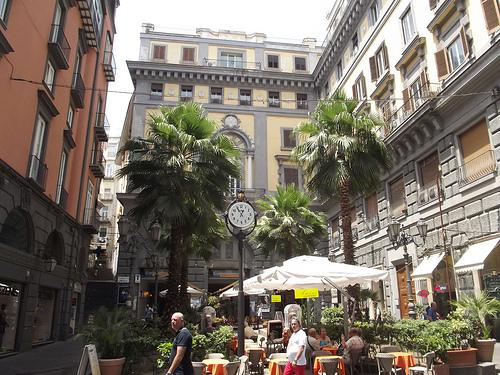Question: what color is the building on the right?
Choices:
A. Yellow.
B. White.
C. Brown.
D. Orange.
Answer with the letter. Answer: D Question: what color of shirt is the person on the right wearing?
Choices:
A. Blue.
B. White.
C. Red.
D. Black.
Answer with the letter. Answer: D Question: what is the number of white tents in the image?
Choices:
A. One.
B. Two.
C. Zero.
D. Six.
Answer with the letter. Answer: A Question: what color are the leave on the palm tree?
Choices:
A. Brown.
B. Green.
C. Orange.
D. Black.
Answer with the letter. Answer: B 